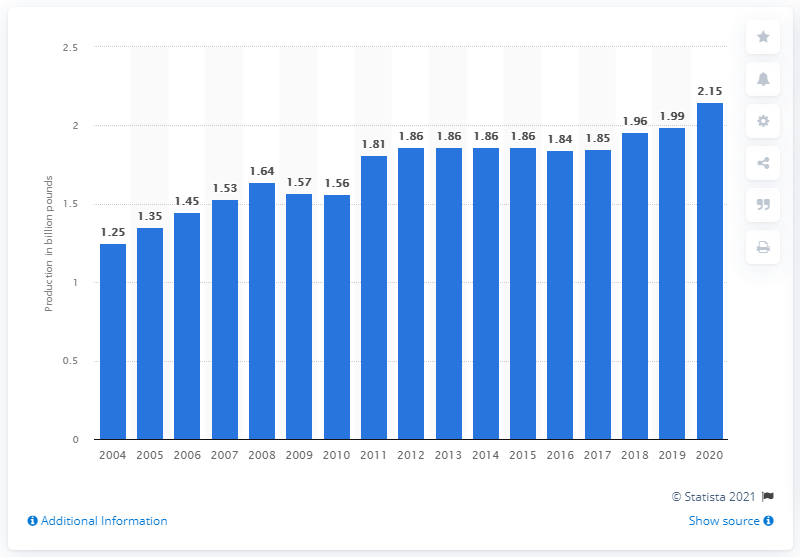Draw attention to some important aspects in this diagram. In 2020, the United States produced approximately 2.15 million metric tons of butter. 